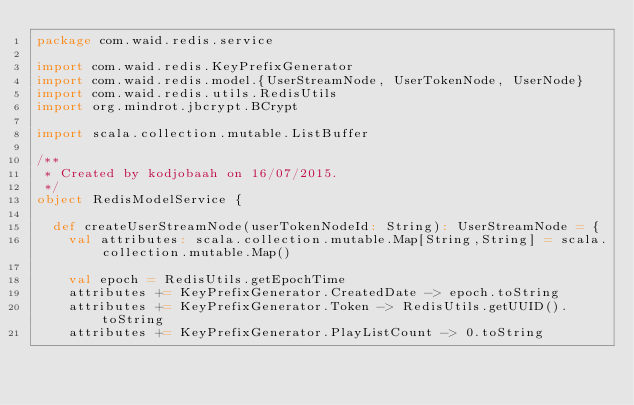<code> <loc_0><loc_0><loc_500><loc_500><_Scala_>package com.waid.redis.service

import com.waid.redis.KeyPrefixGenerator
import com.waid.redis.model.{UserStreamNode, UserTokenNode, UserNode}
import com.waid.redis.utils.RedisUtils
import org.mindrot.jbcrypt.BCrypt

import scala.collection.mutable.ListBuffer

/**
 * Created by kodjobaah on 16/07/2015.
 */
object RedisModelService {

  def createUserStreamNode(userTokenNodeId: String): UserStreamNode = {
    val attributes: scala.collection.mutable.Map[String,String] = scala.collection.mutable.Map()

    val epoch = RedisUtils.getEpochTime
    attributes += KeyPrefixGenerator.CreatedDate -> epoch.toString
    attributes += KeyPrefixGenerator.Token -> RedisUtils.getUUID().toString
    attributes += KeyPrefixGenerator.PlayListCount -> 0.toString
</code> 